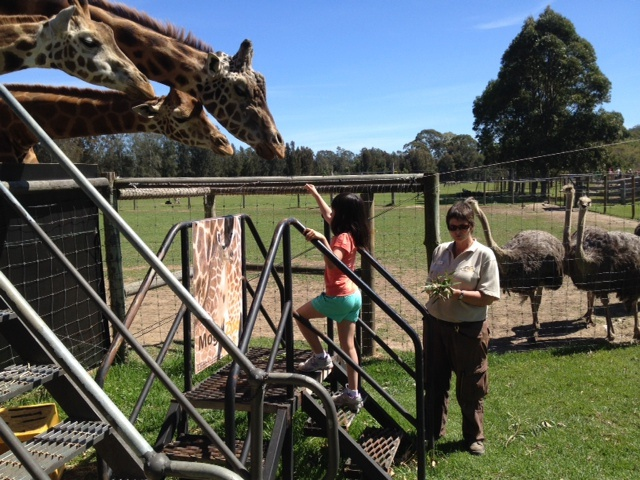Describe the objects in this image and their specific colors. I can see people in black, gray, and maroon tones, giraffe in black and gray tones, giraffe in black, gray, and maroon tones, giraffe in black and gray tones, and people in black, maroon, gray, and darkgreen tones in this image. 